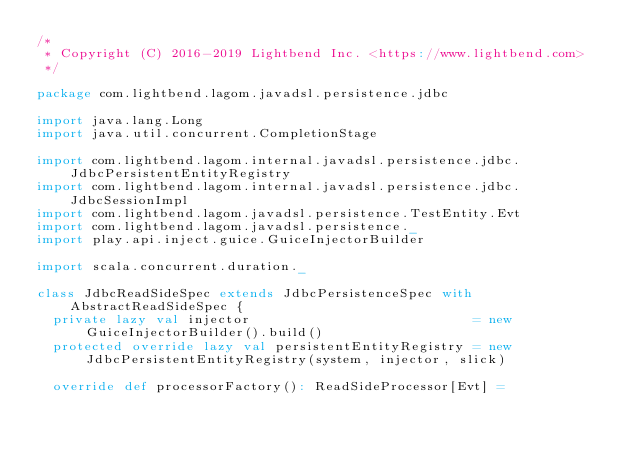<code> <loc_0><loc_0><loc_500><loc_500><_Scala_>/*
 * Copyright (C) 2016-2019 Lightbend Inc. <https://www.lightbend.com>
 */

package com.lightbend.lagom.javadsl.persistence.jdbc

import java.lang.Long
import java.util.concurrent.CompletionStage

import com.lightbend.lagom.internal.javadsl.persistence.jdbc.JdbcPersistentEntityRegistry
import com.lightbend.lagom.internal.javadsl.persistence.jdbc.JdbcSessionImpl
import com.lightbend.lagom.javadsl.persistence.TestEntity.Evt
import com.lightbend.lagom.javadsl.persistence._
import play.api.inject.guice.GuiceInjectorBuilder

import scala.concurrent.duration._

class JdbcReadSideSpec extends JdbcPersistenceSpec with AbstractReadSideSpec {
  private lazy val injector                            = new GuiceInjectorBuilder().build()
  protected override lazy val persistentEntityRegistry = new JdbcPersistentEntityRegistry(system, injector, slick)

  override def processorFactory(): ReadSideProcessor[Evt] =</code> 